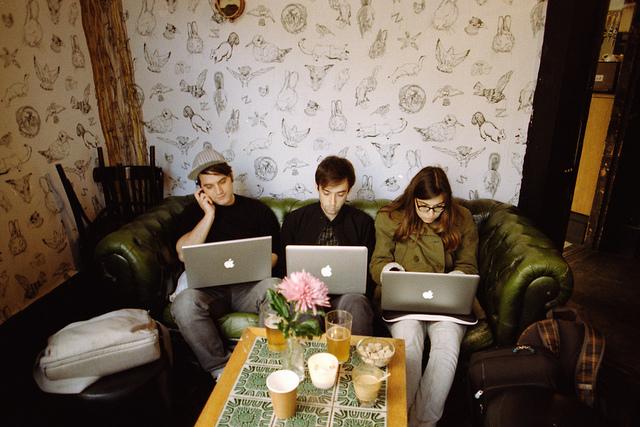Do the laptops have an image of something that you can eat?
Quick response, please. Yes. Where is the flower?
Give a very brief answer. Table. How many laptops are in the picture?
Be succinct. 3. 